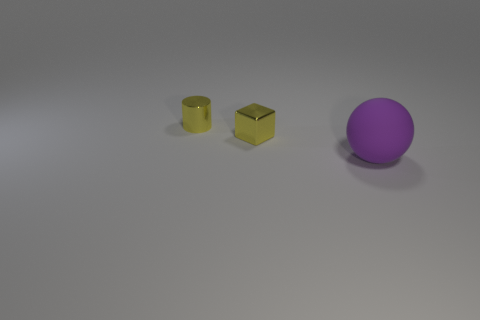Add 2 tiny yellow cubes. How many objects exist? 5 Subtract all blocks. How many objects are left? 2 Subtract all large brown rubber cylinders. Subtract all shiny cubes. How many objects are left? 2 Add 3 purple matte things. How many purple matte things are left? 4 Add 1 tiny yellow metallic objects. How many tiny yellow metallic objects exist? 3 Subtract 0 brown cubes. How many objects are left? 3 